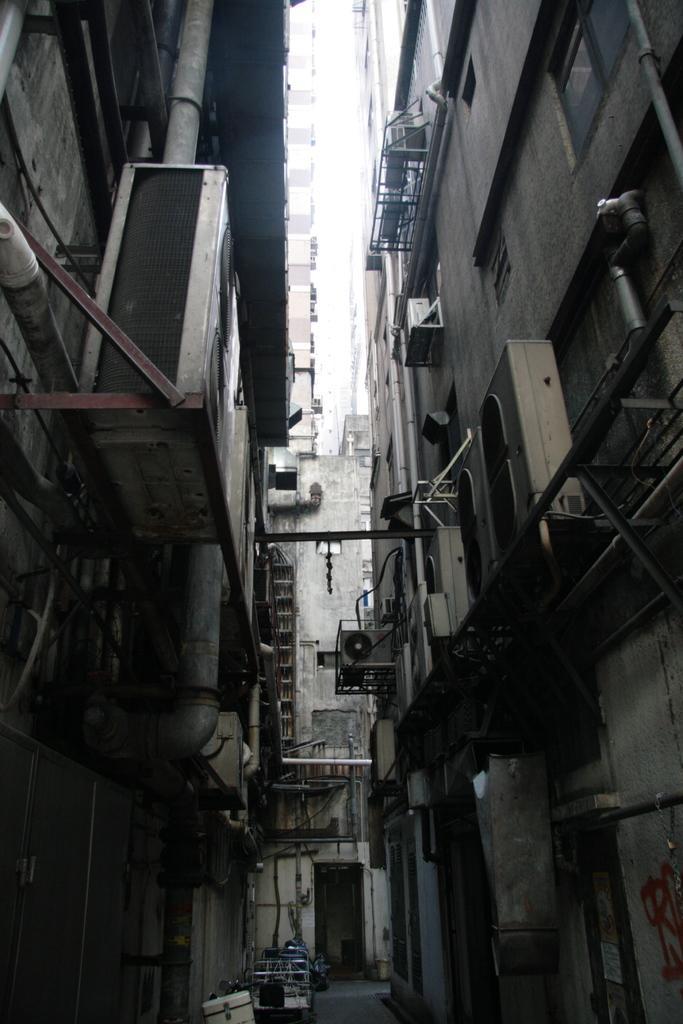Describe this image in one or two sentences. In the image there are buildings on either side with a path in the middle and above its sky. 